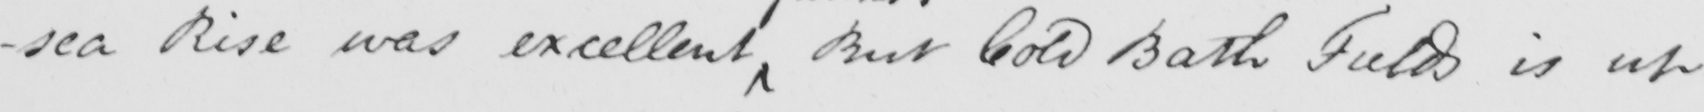Please provide the text content of this handwritten line. Rise was excellent But Cold Bath Fields is up 